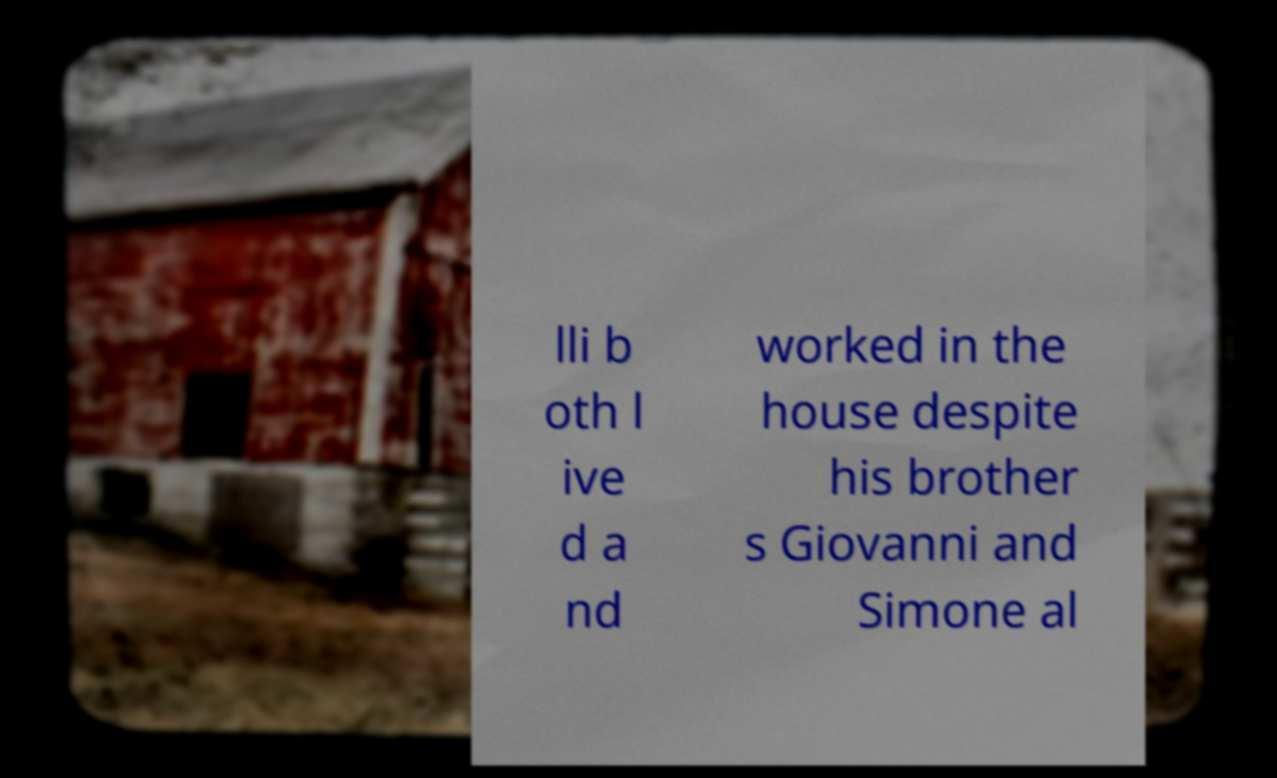Could you assist in decoding the text presented in this image and type it out clearly? lli b oth l ive d a nd worked in the house despite his brother s Giovanni and Simone al 